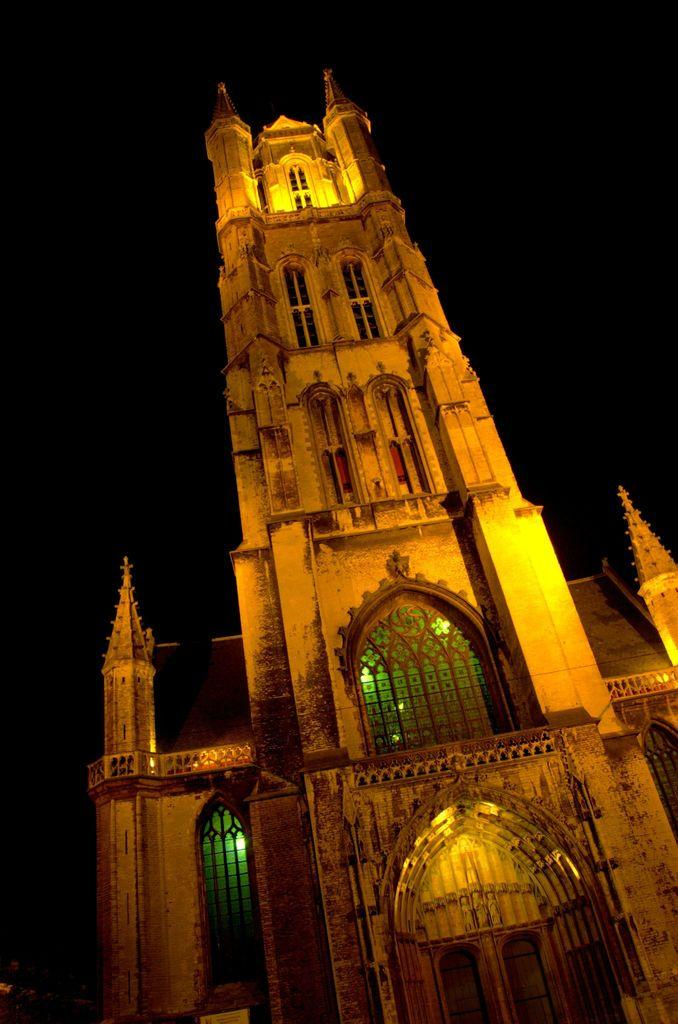What type of structure is visible in the image? There is a building in the image. What architectural features can be seen on the building? The building has pillars, arches, glass windows, and doors. What is the color of the background in the image? The background of the image is dark. What shape is the pest crawling on the building in the image? There is no pest present in the image, so it cannot be determined what shape it might be. What type of gold ornamentation can be seen on the building in the image? There is no gold ornamentation present on the building in the image. 